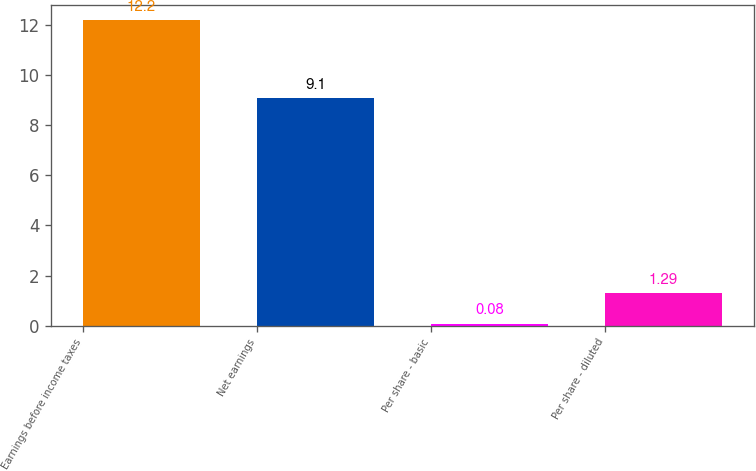Convert chart to OTSL. <chart><loc_0><loc_0><loc_500><loc_500><bar_chart><fcel>Earnings before income taxes<fcel>Net earnings<fcel>Per share - basic<fcel>Per share - diluted<nl><fcel>12.2<fcel>9.1<fcel>0.08<fcel>1.29<nl></chart> 